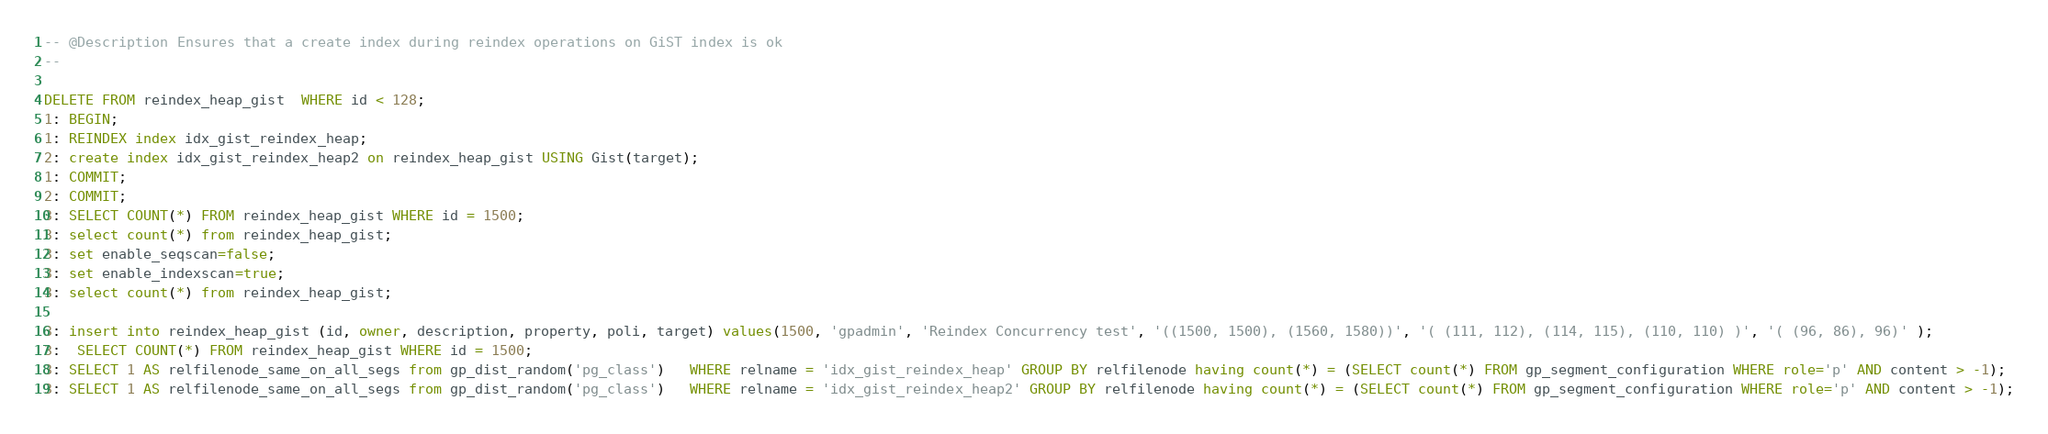<code> <loc_0><loc_0><loc_500><loc_500><_SQL_>-- @Description Ensures that a create index during reindex operations on GiST index is ok
-- 

DELETE FROM reindex_heap_gist  WHERE id < 128;
1: BEGIN;
1: REINDEX index idx_gist_reindex_heap;
2: create index idx_gist_reindex_heap2 on reindex_heap_gist USING Gist(target);
1: COMMIT;
2: COMMIT;
3: SELECT COUNT(*) FROM reindex_heap_gist WHERE id = 1500;
3: select count(*) from reindex_heap_gist;
3: set enable_seqscan=false;
3: set enable_indexscan=true;
3: select count(*) from reindex_heap_gist;

3: insert into reindex_heap_gist (id, owner, description, property, poli, target) values(1500, 'gpadmin', 'Reindex Concurrency test', '((1500, 1500), (1560, 1580))', '( (111, 112), (114, 115), (110, 110) )', '( (96, 86), 96)' );
3:  SELECT COUNT(*) FROM reindex_heap_gist WHERE id = 1500;
3: SELECT 1 AS relfilenode_same_on_all_segs from gp_dist_random('pg_class')   WHERE relname = 'idx_gist_reindex_heap' GROUP BY relfilenode having count(*) = (SELECT count(*) FROM gp_segment_configuration WHERE role='p' AND content > -1);
3: SELECT 1 AS relfilenode_same_on_all_segs from gp_dist_random('pg_class')   WHERE relname = 'idx_gist_reindex_heap2' GROUP BY relfilenode having count(*) = (SELECT count(*) FROM gp_segment_configuration WHERE role='p' AND content > -1);
</code> 